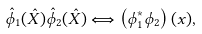Convert formula to latex. <formula><loc_0><loc_0><loc_500><loc_500>\hat { \phi } _ { 1 } ( \hat { X } ) \hat { \phi } _ { 2 } ( \hat { X } ) \Longleftrightarrow \left ( \phi _ { 1 } ^ { * } \phi _ { 2 } \right ) ( x ) ,</formula> 